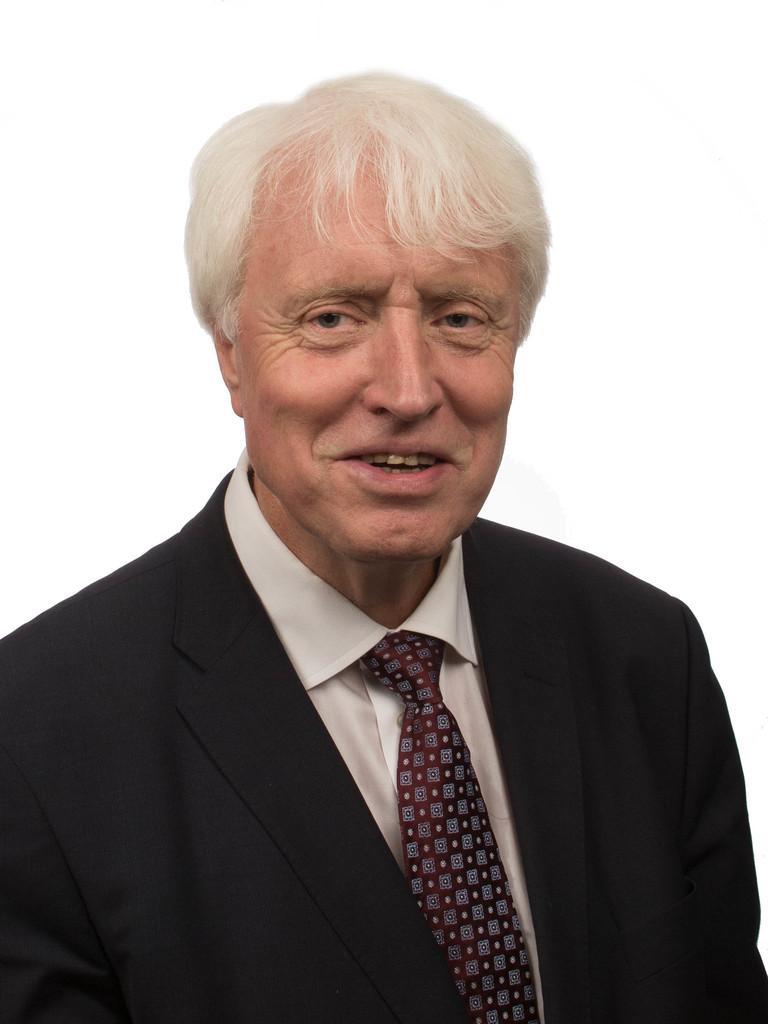Describe this image in one or two sentences. In this image we can see a person smiling. He is wearing a suit. 